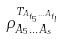Convert formula to latex. <formula><loc_0><loc_0><loc_500><loc_500>\rho _ { A _ { 5 } \dots A _ { s } } ^ { T _ { A _ { t _ { 5 } } \dots A _ { t _ { l } } } }</formula> 